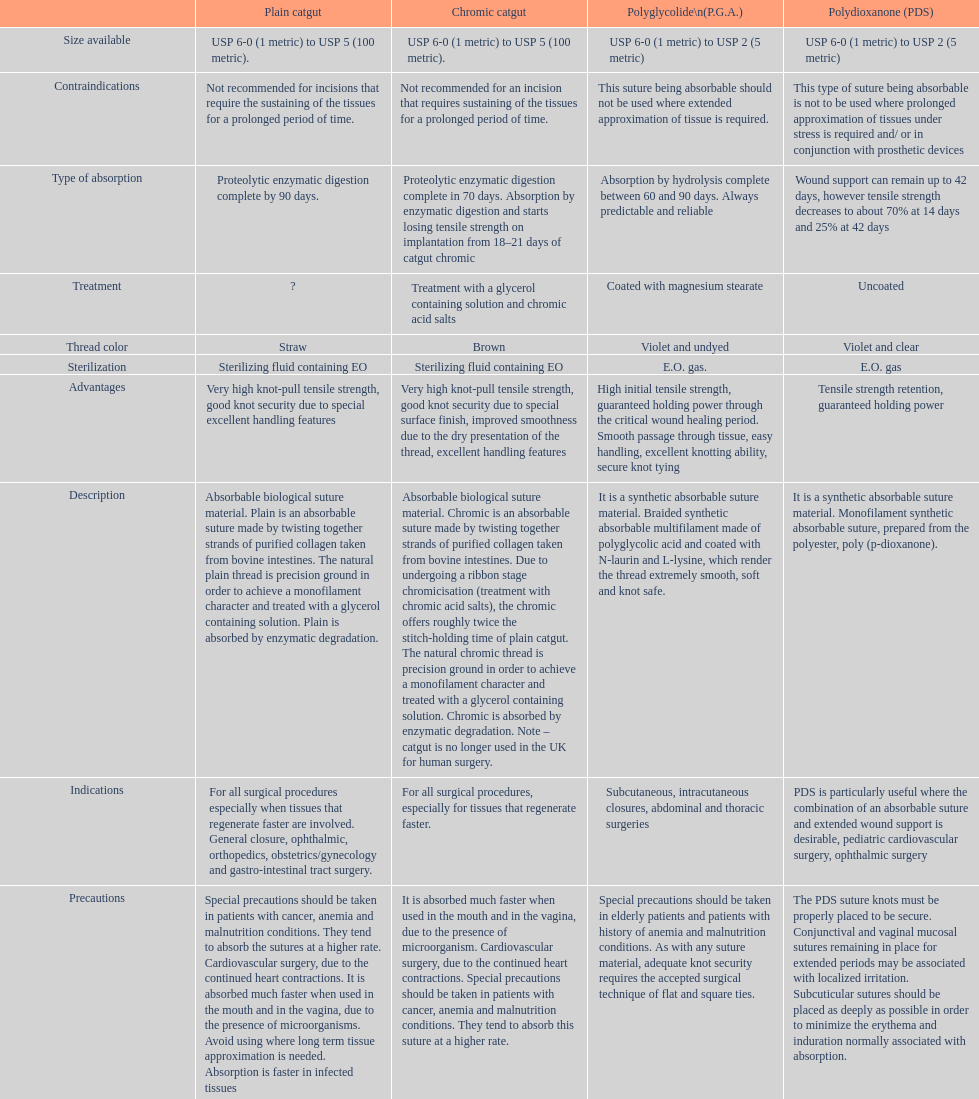What is the structure other than monofilament Braided. 